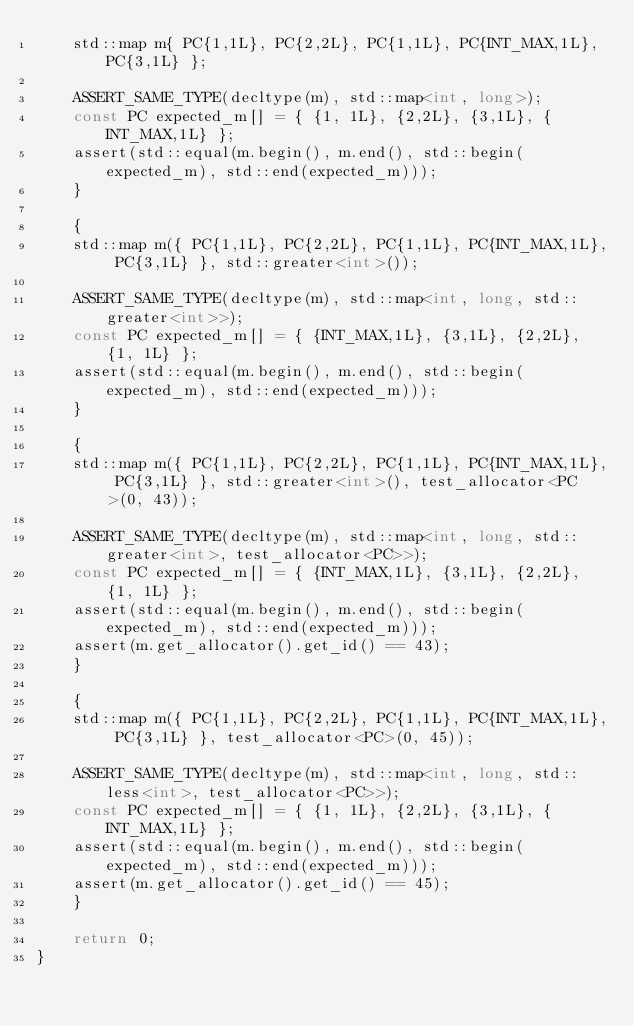Convert code to text. <code><loc_0><loc_0><loc_500><loc_500><_C++_>    std::map m{ PC{1,1L}, PC{2,2L}, PC{1,1L}, PC{INT_MAX,1L}, PC{3,1L} };

    ASSERT_SAME_TYPE(decltype(m), std::map<int, long>);
    const PC expected_m[] = { {1, 1L}, {2,2L}, {3,1L}, {INT_MAX,1L} };
    assert(std::equal(m.begin(), m.end(), std::begin(expected_m), std::end(expected_m)));
    }

    {
    std::map m({ PC{1,1L}, PC{2,2L}, PC{1,1L}, PC{INT_MAX,1L}, PC{3,1L} }, std::greater<int>());

    ASSERT_SAME_TYPE(decltype(m), std::map<int, long, std::greater<int>>);
    const PC expected_m[] = { {INT_MAX,1L}, {3,1L}, {2,2L}, {1, 1L} };
    assert(std::equal(m.begin(), m.end(), std::begin(expected_m), std::end(expected_m)));
    }

    {
    std::map m({ PC{1,1L}, PC{2,2L}, PC{1,1L}, PC{INT_MAX,1L}, PC{3,1L} }, std::greater<int>(), test_allocator<PC>(0, 43));

    ASSERT_SAME_TYPE(decltype(m), std::map<int, long, std::greater<int>, test_allocator<PC>>);
    const PC expected_m[] = { {INT_MAX,1L}, {3,1L}, {2,2L}, {1, 1L} };
    assert(std::equal(m.begin(), m.end(), std::begin(expected_m), std::end(expected_m)));
    assert(m.get_allocator().get_id() == 43);
    }

    {
    std::map m({ PC{1,1L}, PC{2,2L}, PC{1,1L}, PC{INT_MAX,1L}, PC{3,1L} }, test_allocator<PC>(0, 45));

    ASSERT_SAME_TYPE(decltype(m), std::map<int, long, std::less<int>, test_allocator<PC>>);
    const PC expected_m[] = { {1, 1L}, {2,2L}, {3,1L}, {INT_MAX,1L} };
    assert(std::equal(m.begin(), m.end(), std::begin(expected_m), std::end(expected_m)));
    assert(m.get_allocator().get_id() == 45);
    }

    return 0;
}
</code> 